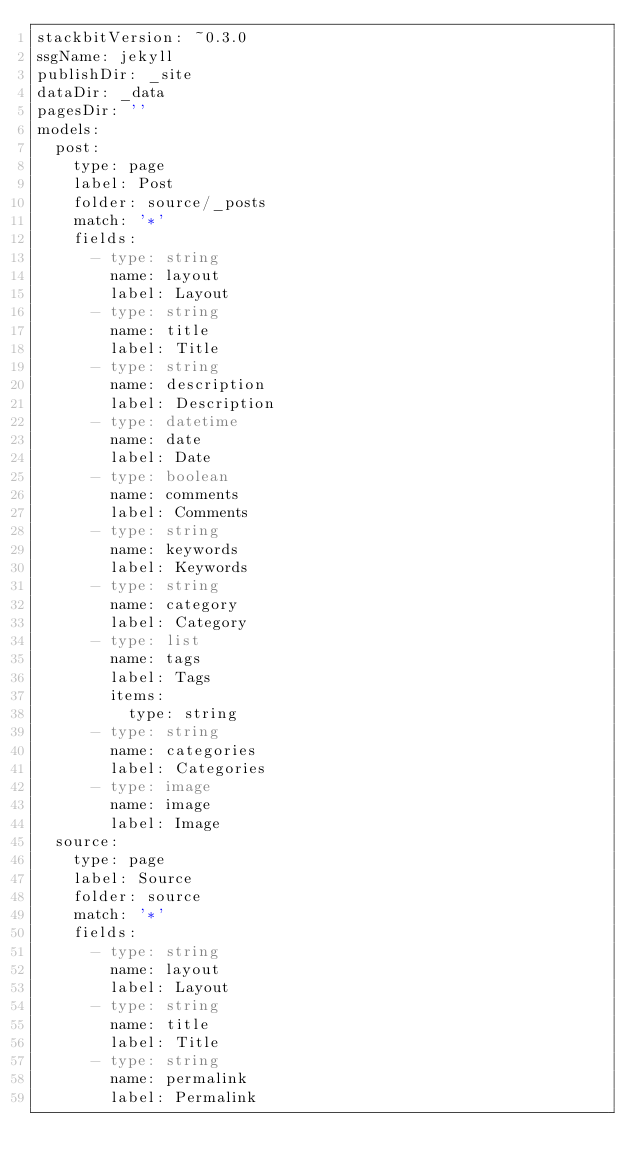<code> <loc_0><loc_0><loc_500><loc_500><_YAML_>stackbitVersion: ~0.3.0
ssgName: jekyll
publishDir: _site
dataDir: _data
pagesDir: ''
models:
  post:
    type: page
    label: Post
    folder: source/_posts
    match: '*'
    fields:
      - type: string
        name: layout
        label: Layout
      - type: string
        name: title
        label: Title
      - type: string
        name: description
        label: Description
      - type: datetime
        name: date
        label: Date
      - type: boolean
        name: comments
        label: Comments
      - type: string
        name: keywords
        label: Keywords
      - type: string
        name: category
        label: Category
      - type: list
        name: tags
        label: Tags
        items:
          type: string
      - type: string
        name: categories
        label: Categories
      - type: image
        name: image
        label: Image
  source:
    type: page
    label: Source
    folder: source
    match: '*'
    fields:
      - type: string
        name: layout
        label: Layout
      - type: string
        name: title
        label: Title
      - type: string
        name: permalink
        label: Permalink
</code> 